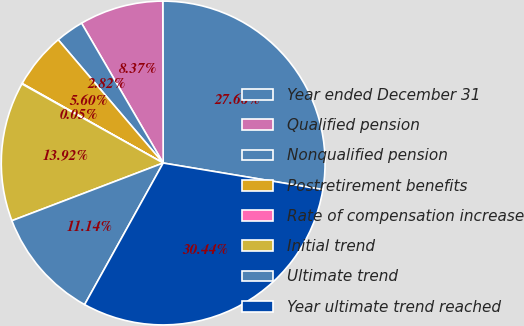Convert chart. <chart><loc_0><loc_0><loc_500><loc_500><pie_chart><fcel>Year ended December 31<fcel>Qualified pension<fcel>Nonqualified pension<fcel>Postretirement benefits<fcel>Rate of compensation increase<fcel>Initial trend<fcel>Ultimate trend<fcel>Year ultimate trend reached<nl><fcel>27.66%<fcel>8.37%<fcel>2.82%<fcel>5.6%<fcel>0.05%<fcel>13.92%<fcel>11.14%<fcel>30.44%<nl></chart> 